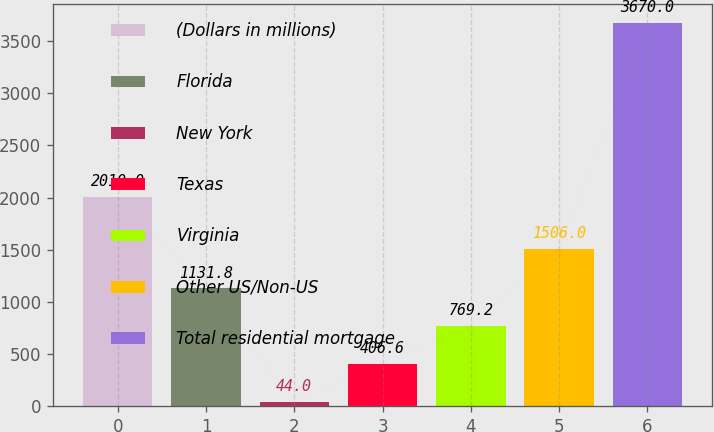Convert chart to OTSL. <chart><loc_0><loc_0><loc_500><loc_500><bar_chart><fcel>(Dollars in millions)<fcel>Florida<fcel>New York<fcel>Texas<fcel>Virginia<fcel>Other US/Non-US<fcel>Total residential mortgage<nl><fcel>2010<fcel>1131.8<fcel>44<fcel>406.6<fcel>769.2<fcel>1506<fcel>3670<nl></chart> 